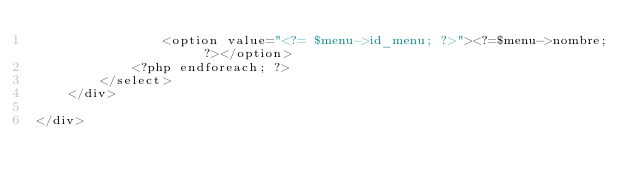Convert code to text. <code><loc_0><loc_0><loc_500><loc_500><_PHP_>                <option value="<?= $menu->id_menu; ?>"><?=$menu->nombre; ?></option>
            <?php endforeach; ?>
        </select>
    </div>

</div>

</code> 